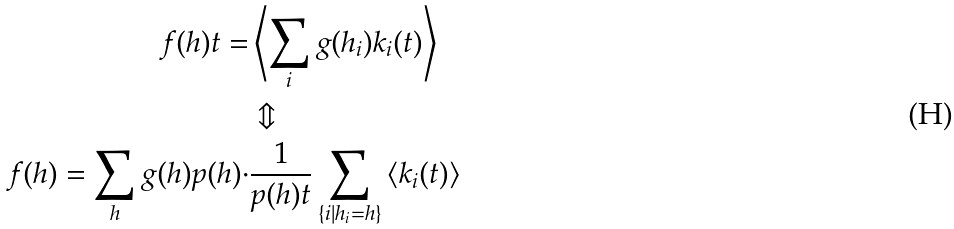<formula> <loc_0><loc_0><loc_500><loc_500>f ( h ) t = & \left \langle \sum _ { i } g ( h _ { i } ) k _ { i } ( t ) \right \rangle \quad \\ & \Updownarrow \\ \quad f ( h ) = \sum _ { h } g ( h ) p ( h ) \cdot & \frac { 1 } { p ( h ) t } \sum _ { \{ i | h _ { i } = h \} } \left \langle k _ { i } ( t ) \right \rangle</formula> 